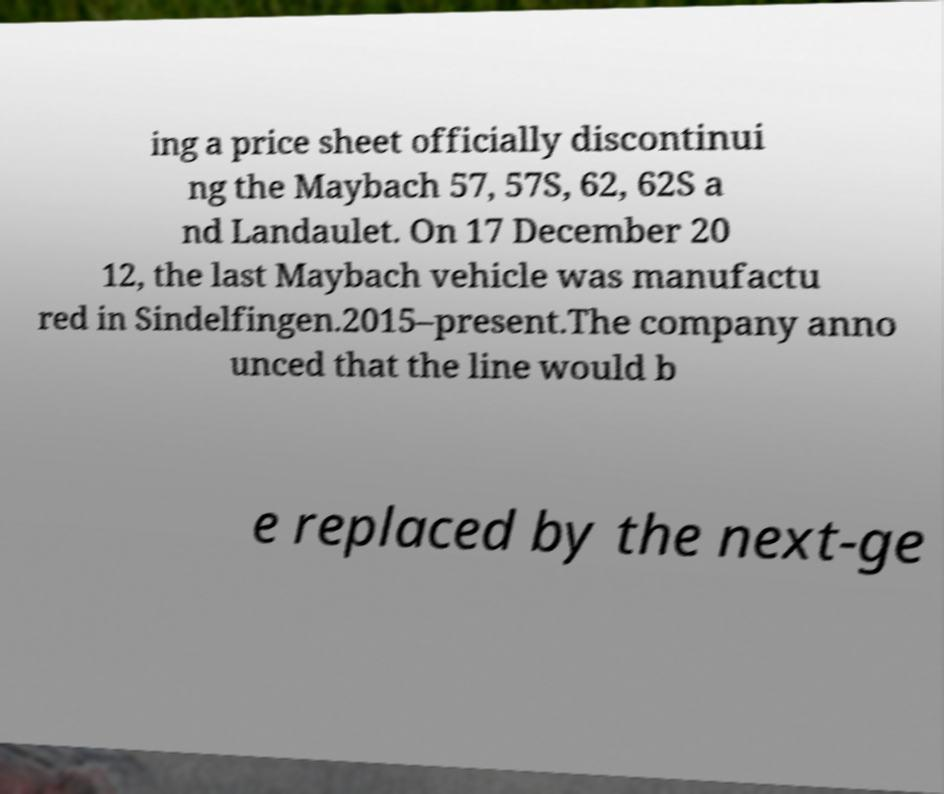Could you extract and type out the text from this image? ing a price sheet officially discontinui ng the Maybach 57, 57S, 62, 62S a nd Landaulet. On 17 December 20 12, the last Maybach vehicle was manufactu red in Sindelfingen.2015–present.The company anno unced that the line would b e replaced by the next-ge 